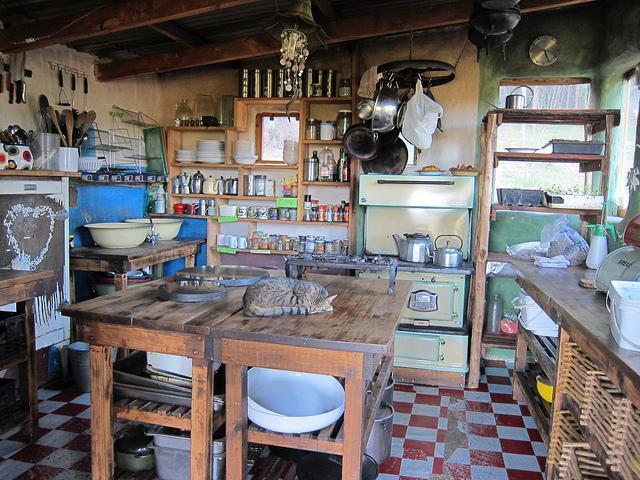What is in the kitchen but unnecessary for cooking or baking?
Answer the question by selecting the correct answer among the 4 following choices and explain your choice with a short sentence. The answer should be formatted with the following format: `Answer: choice
Rationale: rationale.`
Options: Blanket, radio, bassinet, cat. Answer: cat.
Rationale: The cat isn't needed to bake or cook. 